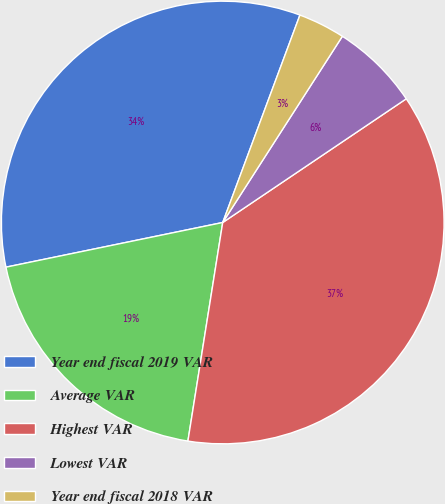Convert chart to OTSL. <chart><loc_0><loc_0><loc_500><loc_500><pie_chart><fcel>Year end fiscal 2019 VAR<fcel>Average VAR<fcel>Highest VAR<fcel>Lowest VAR<fcel>Year end fiscal 2018 VAR<nl><fcel>33.9%<fcel>19.25%<fcel>36.95%<fcel>6.47%<fcel>3.42%<nl></chart> 